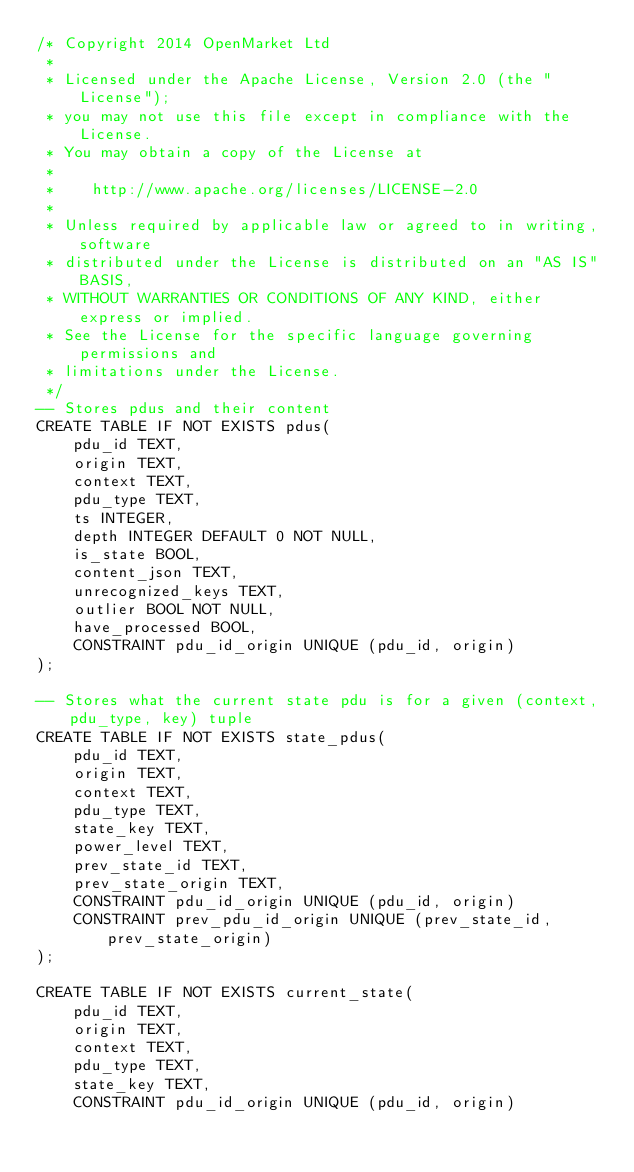Convert code to text. <code><loc_0><loc_0><loc_500><loc_500><_SQL_>/* Copyright 2014 OpenMarket Ltd
 *
 * Licensed under the Apache License, Version 2.0 (the "License");
 * you may not use this file except in compliance with the License.
 * You may obtain a copy of the License at
 *
 *    http://www.apache.org/licenses/LICENSE-2.0
 *
 * Unless required by applicable law or agreed to in writing, software
 * distributed under the License is distributed on an "AS IS" BASIS,
 * WITHOUT WARRANTIES OR CONDITIONS OF ANY KIND, either express or implied.
 * See the License for the specific language governing permissions and
 * limitations under the License.
 */
-- Stores pdus and their content
CREATE TABLE IF NOT EXISTS pdus(
    pdu_id TEXT, 
    origin TEXT, 
    context TEXT,
    pdu_type TEXT,
    ts INTEGER,
    depth INTEGER DEFAULT 0 NOT NULL,
    is_state BOOL, 
    content_json TEXT,
    unrecognized_keys TEXT,
    outlier BOOL NOT NULL,
    have_processed BOOL, 
    CONSTRAINT pdu_id_origin UNIQUE (pdu_id, origin)
);

-- Stores what the current state pdu is for a given (context, pdu_type, key) tuple
CREATE TABLE IF NOT EXISTS state_pdus(
    pdu_id TEXT,
    origin TEXT,
    context TEXT,
    pdu_type TEXT,
    state_key TEXT,
    power_level TEXT,
    prev_state_id TEXT,
    prev_state_origin TEXT,
    CONSTRAINT pdu_id_origin UNIQUE (pdu_id, origin)
    CONSTRAINT prev_pdu_id_origin UNIQUE (prev_state_id, prev_state_origin)
);

CREATE TABLE IF NOT EXISTS current_state(
    pdu_id TEXT,
    origin TEXT,
    context TEXT,
    pdu_type TEXT,
    state_key TEXT,
    CONSTRAINT pdu_id_origin UNIQUE (pdu_id, origin)</code> 